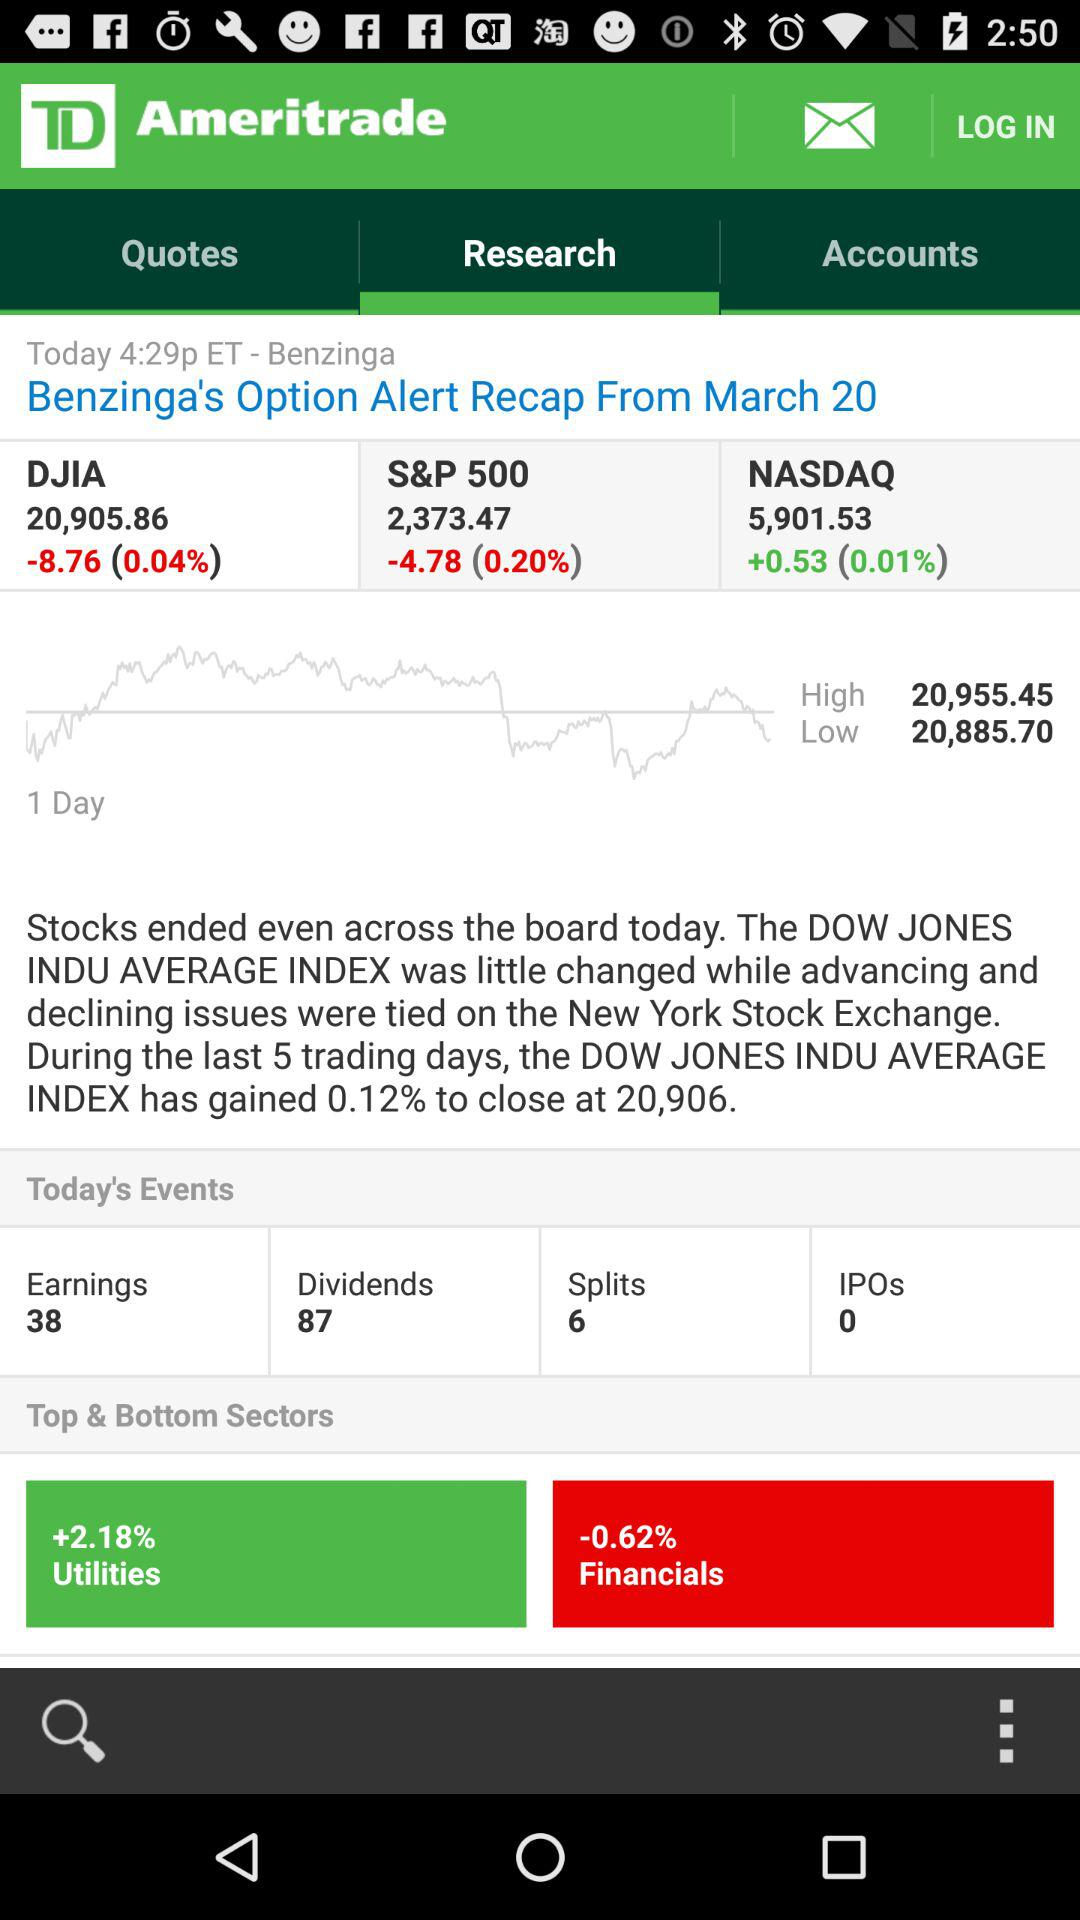What might be the cause for the Utilities sector to perform well? Utilities sector performance can be influenced by several factors such as regulatory changes, weather-related demand fluctuations, and market volatility. The high percentage gain may suggest investor confidence in the sector's stability or reaction to specific news or economic indicators. 